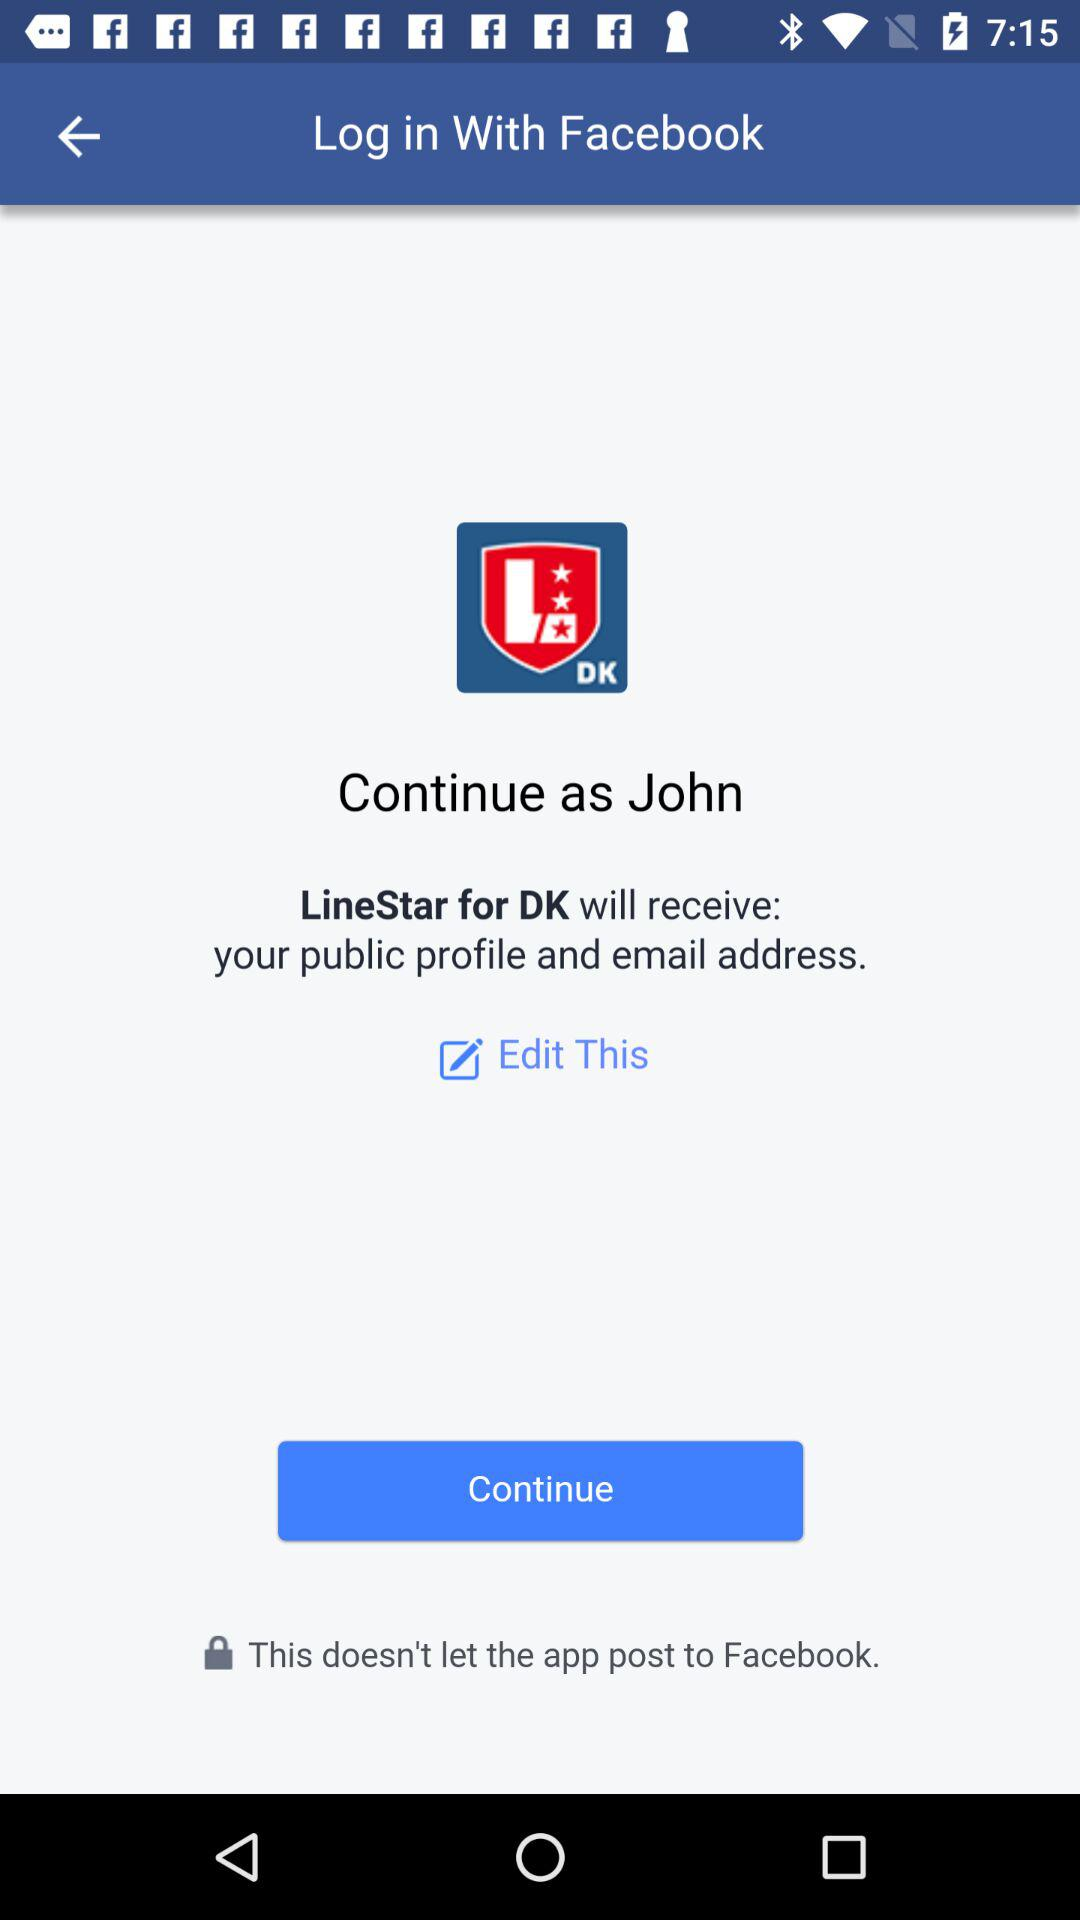What applications can be used to log in to a profile? The application that can be used to log in to a profile is Facebook. 